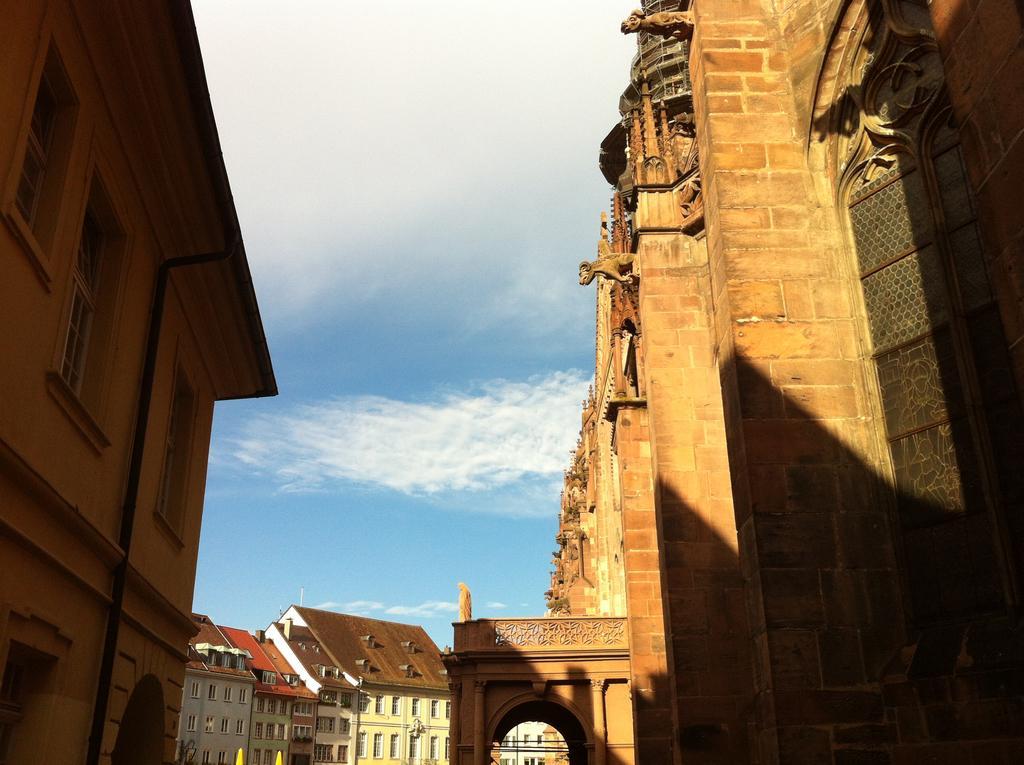How would you summarize this image in a sentence or two? This image is taken outdoors. At the top of the image there is the sky with clouds. On the left side of the image there is a building. On the right side of the image there is an architecture with walls, sculptures and carvings. In the middle of the image there are two buildings. 